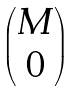Convert formula to latex. <formula><loc_0><loc_0><loc_500><loc_500>\begin{pmatrix} M \\ 0 \end{pmatrix}</formula> 